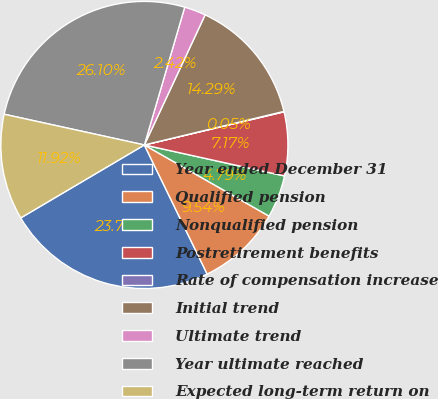Convert chart to OTSL. <chart><loc_0><loc_0><loc_500><loc_500><pie_chart><fcel>Year ended December 31<fcel>Qualified pension<fcel>Nonqualified pension<fcel>Postretirement benefits<fcel>Rate of compensation increase<fcel>Initial trend<fcel>Ultimate trend<fcel>Year ultimate reached<fcel>Expected long-term return on<nl><fcel>23.72%<fcel>9.54%<fcel>4.79%<fcel>7.17%<fcel>0.05%<fcel>14.29%<fcel>2.42%<fcel>26.1%<fcel>11.92%<nl></chart> 